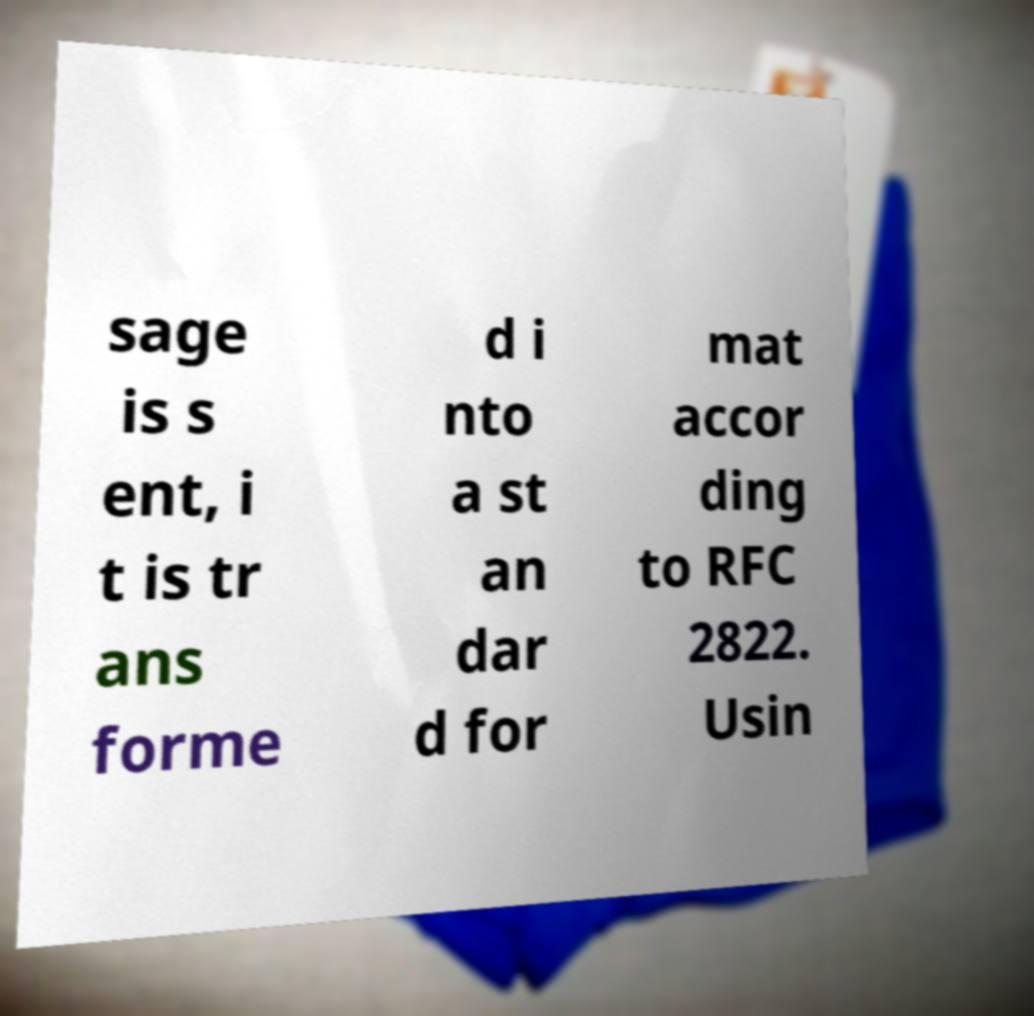Could you extract and type out the text from this image? sage is s ent, i t is tr ans forme d i nto a st an dar d for mat accor ding to RFC 2822. Usin 